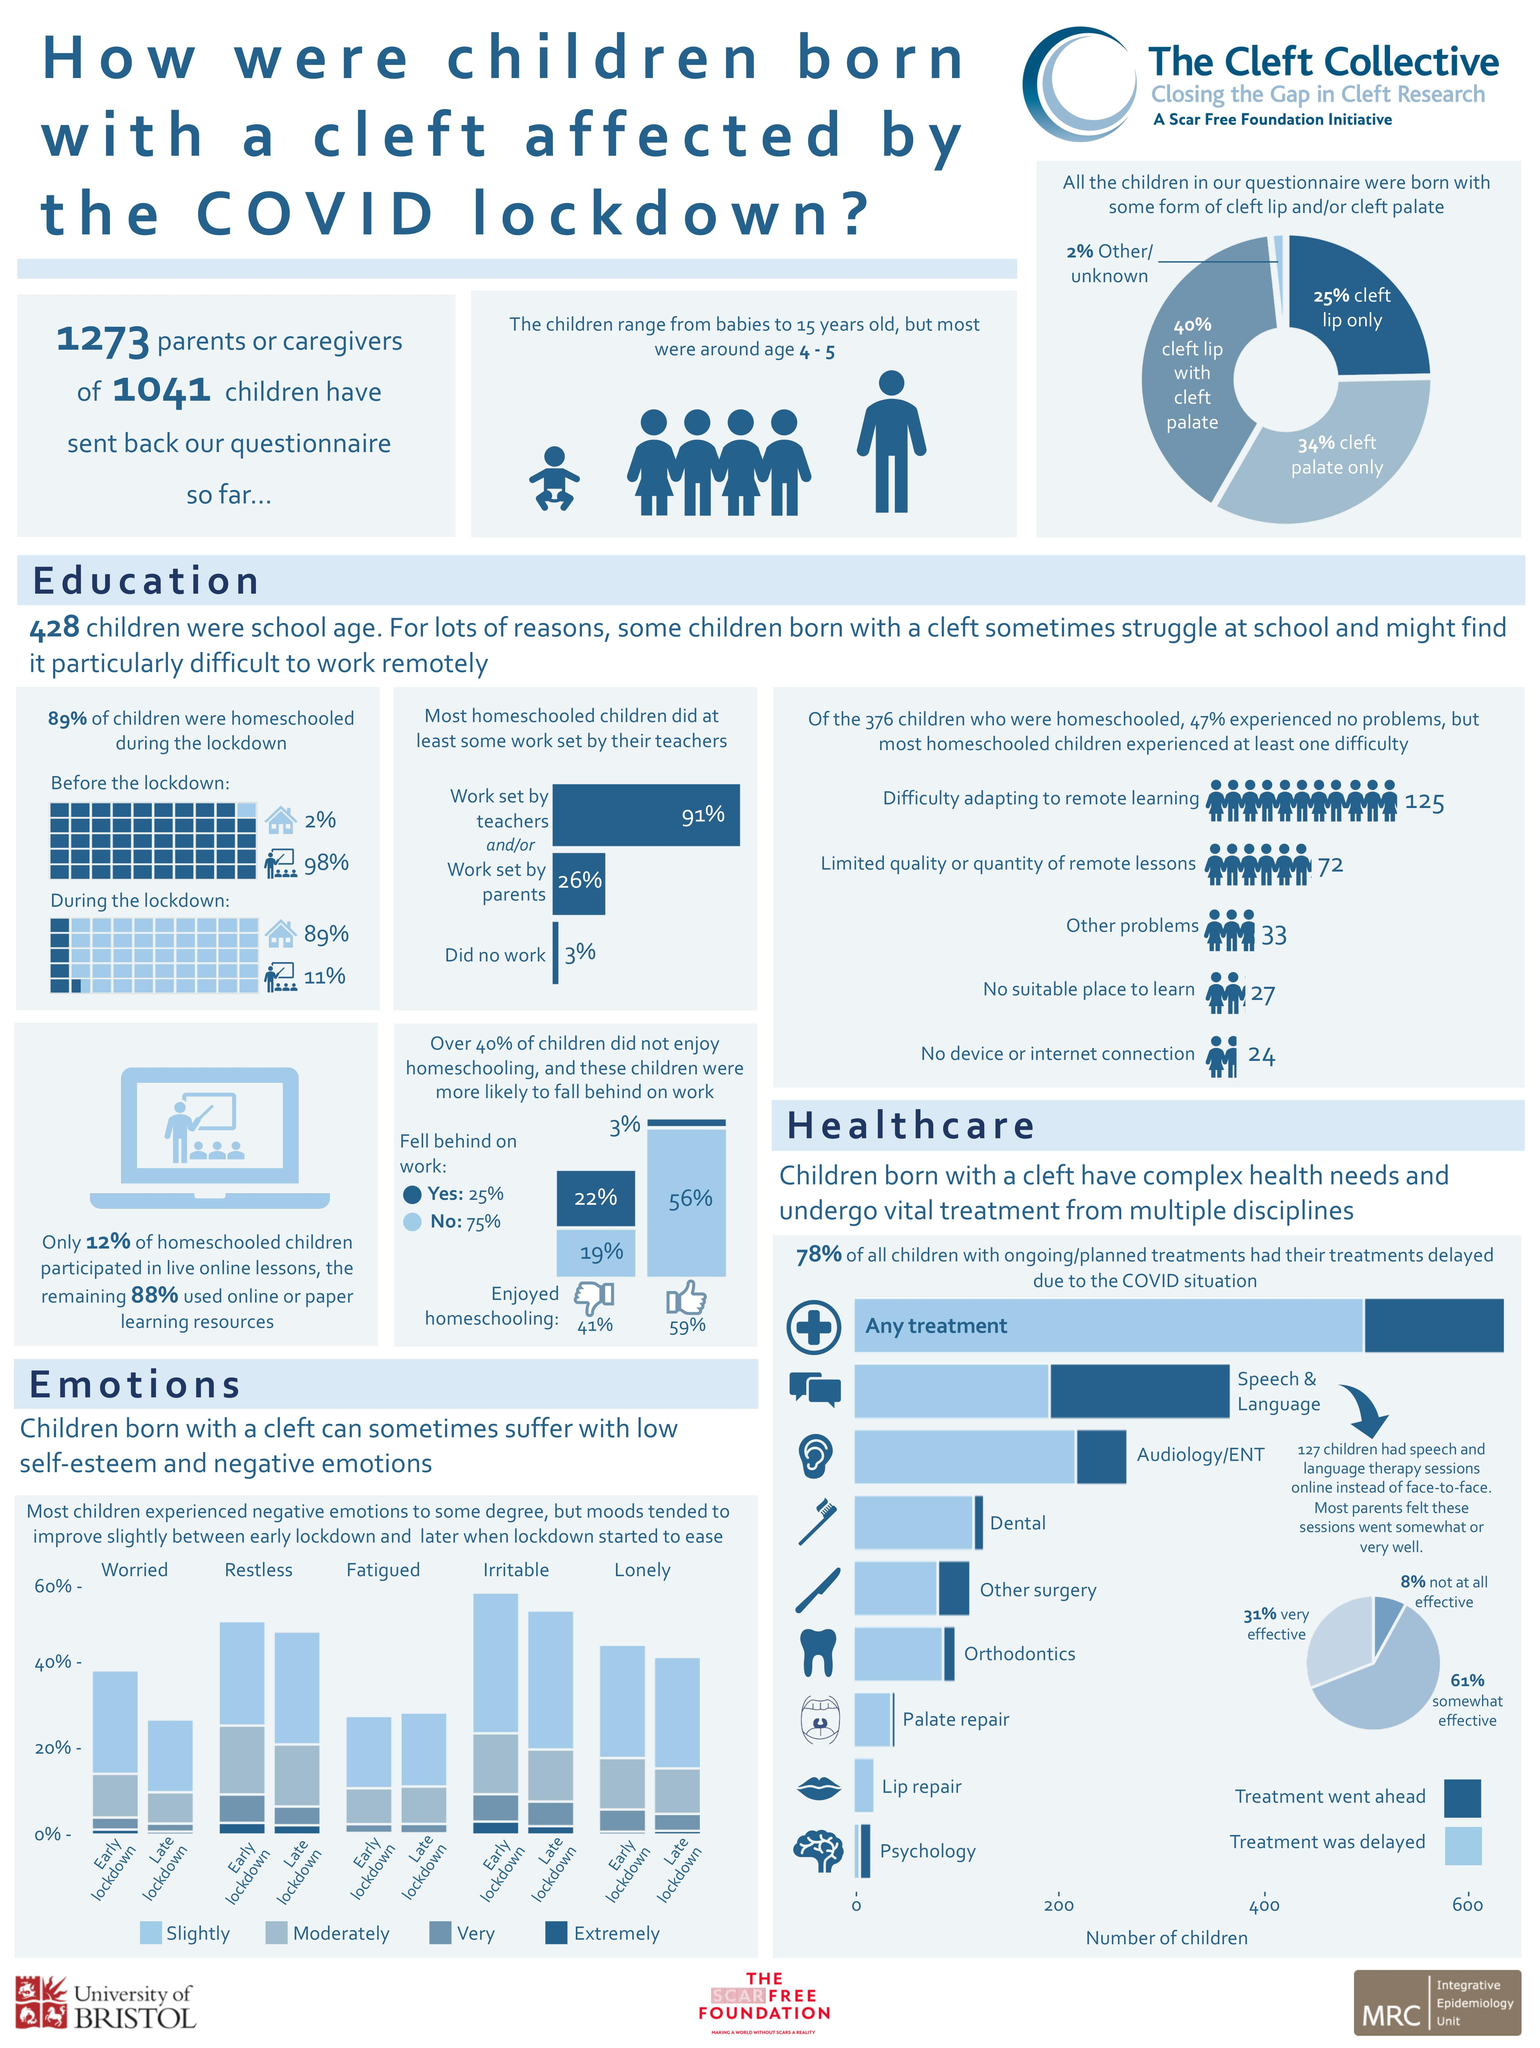Identify some key points in this picture. According to official records, only 2% of the children in the school were homeschooled before the lockdown. None of the children had their planned lip repair treatment due to the COVID-19 situation. During the lockdown, only 11% of the children attended regular school. According to the given statistic, only 3% of the children who enjoyed being homeschooled fell behind on their work. According to a recent survey, 59% of all children reported enjoying being homeschooled. 